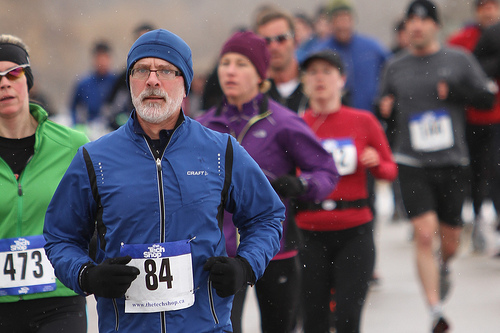<image>
Is the young man behind the elderly man? No. The young man is not behind the elderly man. From this viewpoint, the young man appears to be positioned elsewhere in the scene. Where is the eight in relation to the seven? Is it to the right of the seven? Yes. From this viewpoint, the eight is positioned to the right side relative to the seven. 